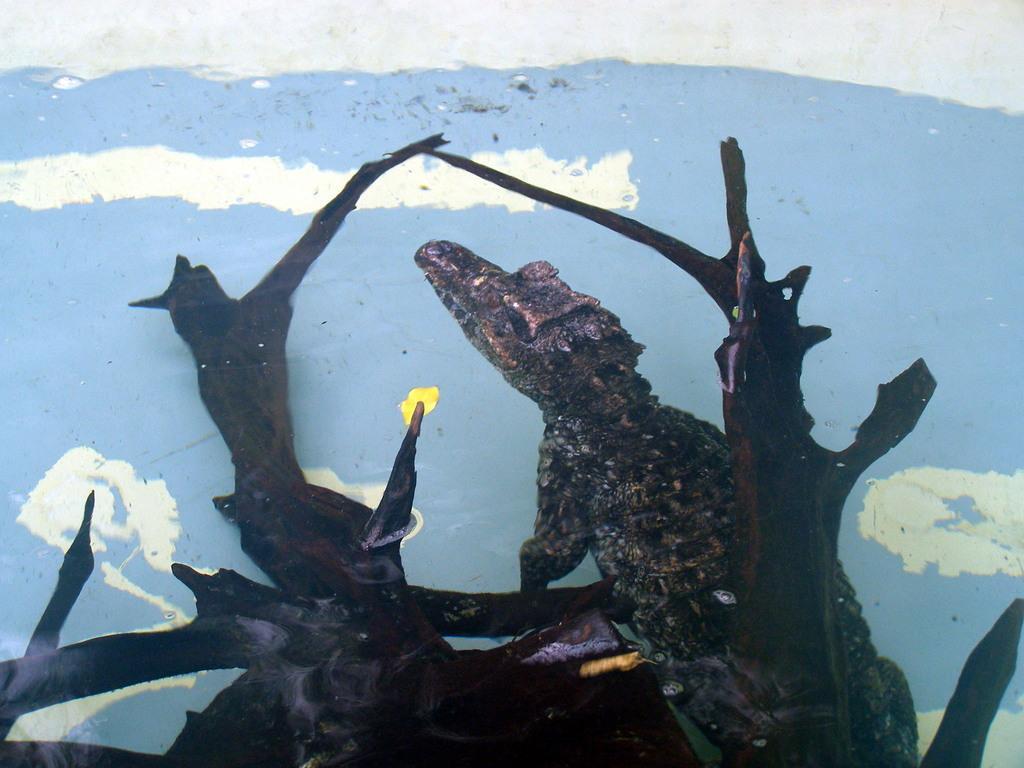How would you summarize this image in a sentence or two? In this image there is a reptile towards the bottom of the image on a wooden object, at the background of the image there is a wall. 